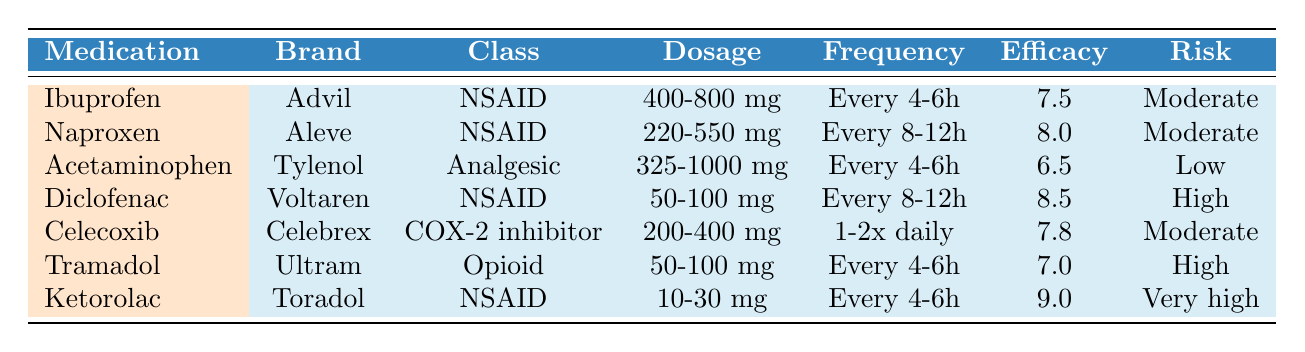What is the recommended dosage range for Ibuprofen? The table lists the common dosage for Ibuprofen as 400-800 mg.
Answer: 400-800 mg Which medication has the highest efficacy rating? By comparing the efficacy ratings, Ketorolac has the highest rating of 9.0.
Answer: Ketorolac Does Acetaminophen have a low side effects risk? The table indicates that Acetaminophen has a low risk for side effects.
Answer: Yes What is the frequency of Tramadol administration? According to the table, Tramadol should be taken every 4-6 hours.
Answer: Every 4-6 hours What is the onset of action for Diclofenac? The table specifies that the onset of action for Diclofenac is 30-60 minutes.
Answer: 30-60 minutes Which medications are recommended for muscle strains? The table states that Ibuprofen is recommended for muscle strains.
Answer: Ibuprofen How do the efficacy ratings of Naproxen and Celecoxib compare? Naproxen has an efficacy rating of 8.0, while Celecoxib has a rating of 7.8, making Naproxen slightly more effective.
Answer: Naproxen is higher Is Ketorolac contraindicated for those with bleeding disorders? The table states that Ketorolac is contraindicated for bleeding disorders, confirming this fact.
Answer: Yes Which medication can be taken once or twice daily? The table shows that Celecoxib is the only medication listed with that frequency.
Answer: Celecoxib If a patient has a liver disease, which medication should they avoid? Since Acetaminophen is contraindicated for liver disease, this medication should be avoided.
Answer: Acetaminophen What is the average efficacy rating of the NSAIDs listed? The NSAIDs listed are Ibuprofen (7.5), Naproxen (8.0), Diclofenac (8.5), and Ketorolac (9.0). The average is (7.5 + 8.0 + 8.5 + 9.0) / 4 = 8.25.
Answer: 8.25 Among the medications, which has the highest risk for side effects? Ketorolac has the highest risk of side effects listed as "Very high" in the table.
Answer: Ketorolac Are there any medications recommended for arthritis? Yes, Naproxen and Celecoxib are both recommended for arthritis.
Answer: Yes, Naproxen and Celecoxib What is the total number of medications classified as NSAIDs in the table? The table lists four medications as NSAIDs: Ibuprofen, Naproxen, Diclofenac, and Ketorolac, totaling four NSAIDs.
Answer: 4 If a patient is allergic to sulfa, which medication should they avoid? The patient should avoid Celecoxib, as it is contraindicated for those with a sulfa allergy.
Answer: Celecoxib 